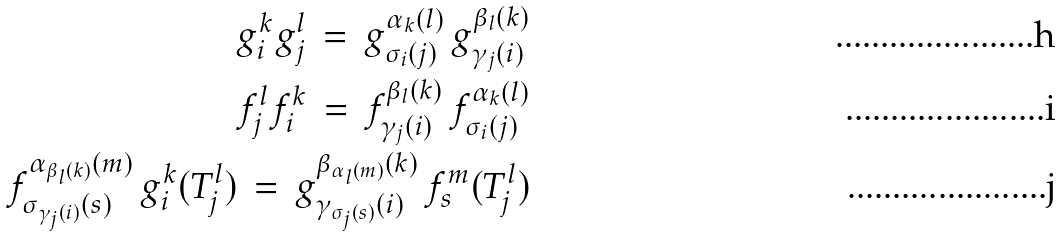Convert formula to latex. <formula><loc_0><loc_0><loc_500><loc_500>g _ { i } ^ { k } g _ { j } ^ { l } \, = \, g _ { \sigma _ { i } ( j ) } ^ { \alpha _ { k } ( l ) } \, g _ { \gamma _ { j } ( i ) } ^ { \beta _ { l } ( k ) } \\ f _ { j } ^ { l } f _ { i } ^ { k } \, = \, f _ { \gamma _ { j } ( i ) } ^ { \beta _ { l } ( k ) } \, f _ { \sigma _ { i } ( j ) } ^ { \alpha _ { k } ( l ) } \\ f _ { \sigma _ { \gamma _ { j } ( i ) } ( s ) } ^ { \alpha _ { \beta _ { l } ( k ) } ( m ) } \, g _ { i } ^ { k } ( T _ { j } ^ { l } ) \, = \, g _ { \gamma _ { \sigma _ { j } ( s ) } ( i ) } ^ { \beta _ { \alpha _ { l } ( m ) } ( k ) } \, f _ { s } ^ { m } ( T _ { j } ^ { l } )</formula> 